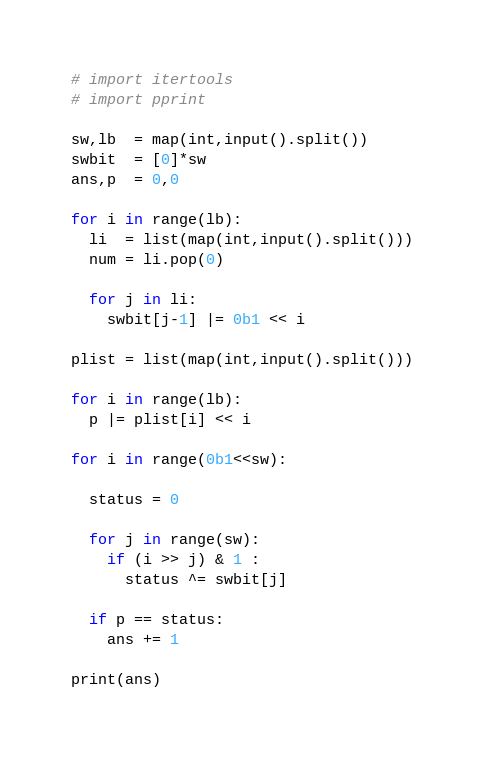Convert code to text. <code><loc_0><loc_0><loc_500><loc_500><_Python_># import itertools
# import pprint

sw,lb  = map(int,input().split())
swbit  = [0]*sw
ans,p  = 0,0

for i in range(lb):
  li  = list(map(int,input().split()))
  num = li.pop(0)

  for j in li:
    swbit[j-1] |= 0b1 << i

plist = list(map(int,input().split()))

for i in range(lb):
  p |= plist[i] << i

for i in range(0b1<<sw):
  
  status = 0

  for j in range(sw):
    if (i >> j) & 1 :
      status ^= swbit[j]
  
  if p == status:
    ans += 1

print(ans)
</code> 